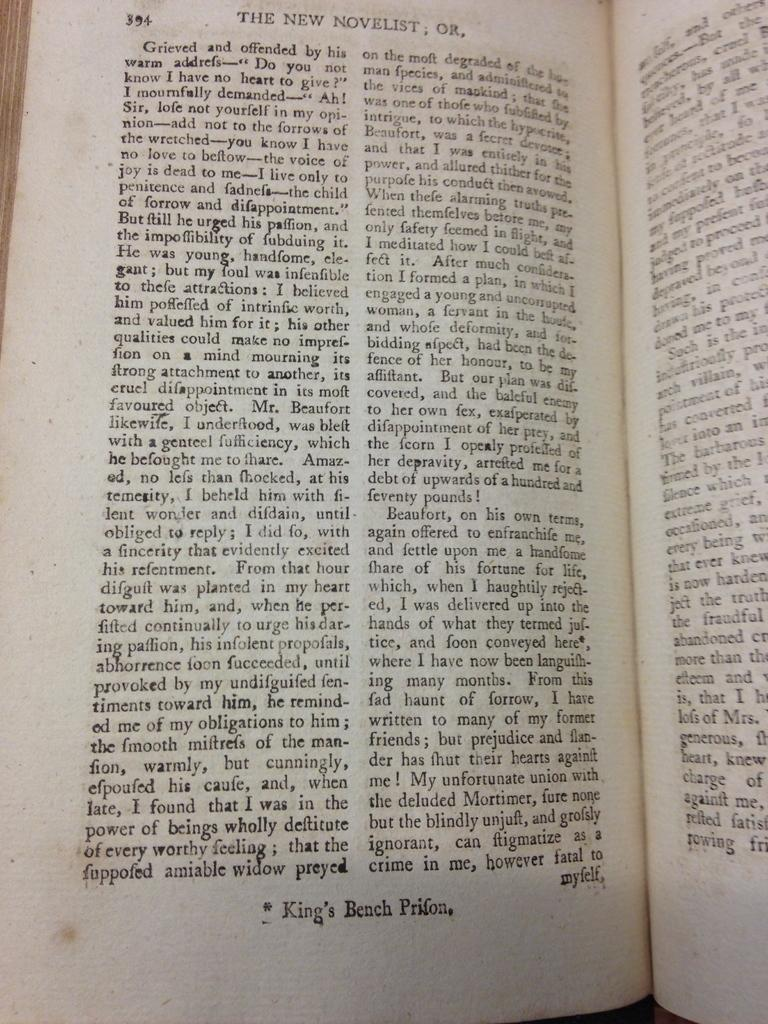<image>
Give a short and clear explanation of the subsequent image. King's Bench Prifon opened to page 394 and at the top it reads the new novelist. 